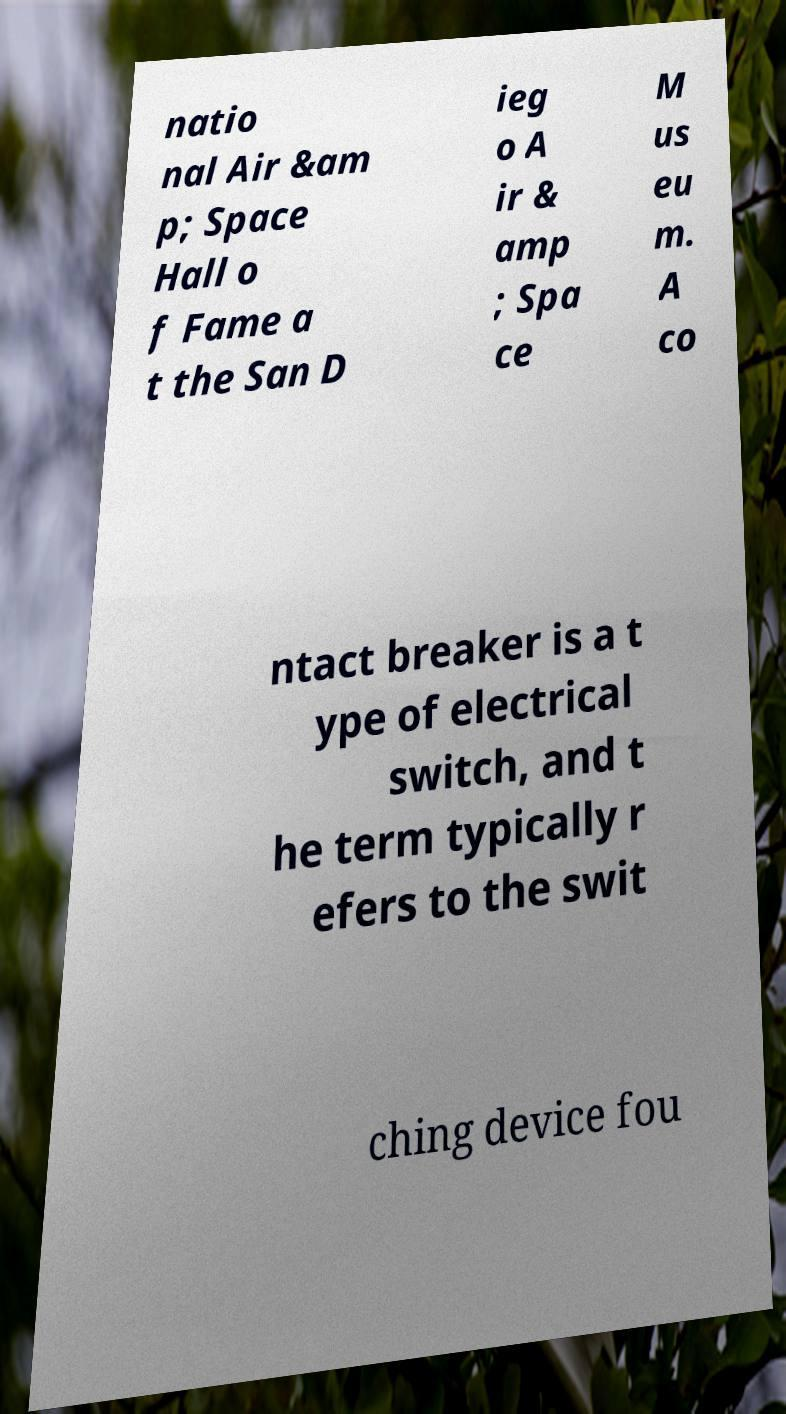Please read and relay the text visible in this image. What does it say? natio nal Air &am p; Space Hall o f Fame a t the San D ieg o A ir & amp ; Spa ce M us eu m. A co ntact breaker is a t ype of electrical switch, and t he term typically r efers to the swit ching device fou 